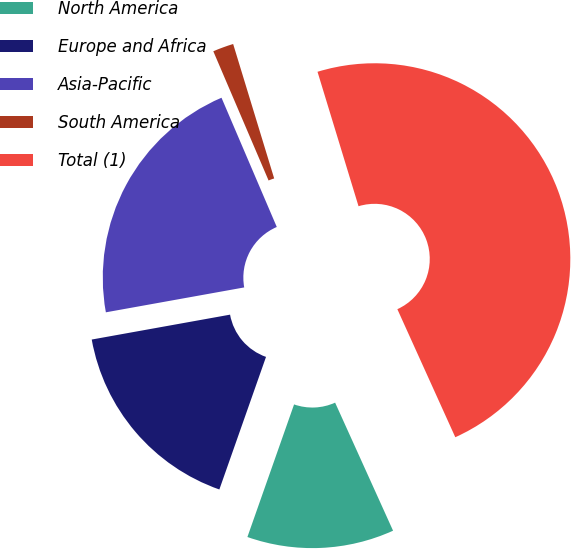Convert chart. <chart><loc_0><loc_0><loc_500><loc_500><pie_chart><fcel>North America<fcel>Europe and Africa<fcel>Asia-Pacific<fcel>South America<fcel>Total (1)<nl><fcel>12.15%<fcel>16.78%<fcel>21.4%<fcel>1.72%<fcel>47.95%<nl></chart> 